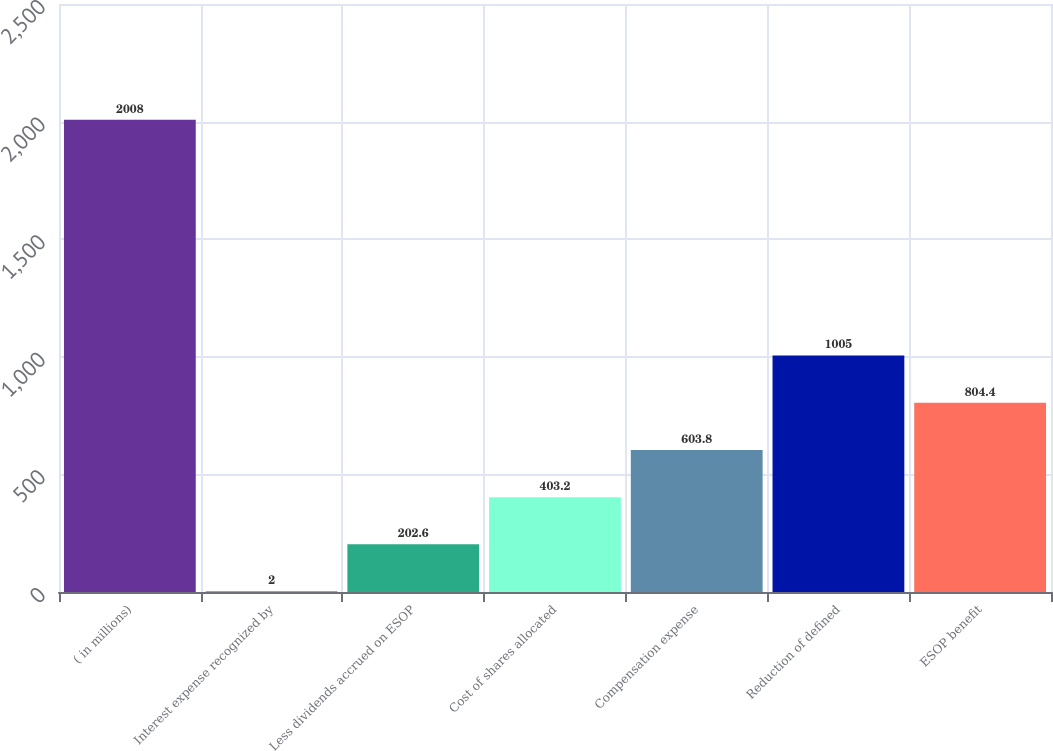<chart> <loc_0><loc_0><loc_500><loc_500><bar_chart><fcel>( in millions)<fcel>Interest expense recognized by<fcel>Less dividends accrued on ESOP<fcel>Cost of shares allocated<fcel>Compensation expense<fcel>Reduction of defined<fcel>ESOP benefit<nl><fcel>2008<fcel>2<fcel>202.6<fcel>403.2<fcel>603.8<fcel>1005<fcel>804.4<nl></chart> 